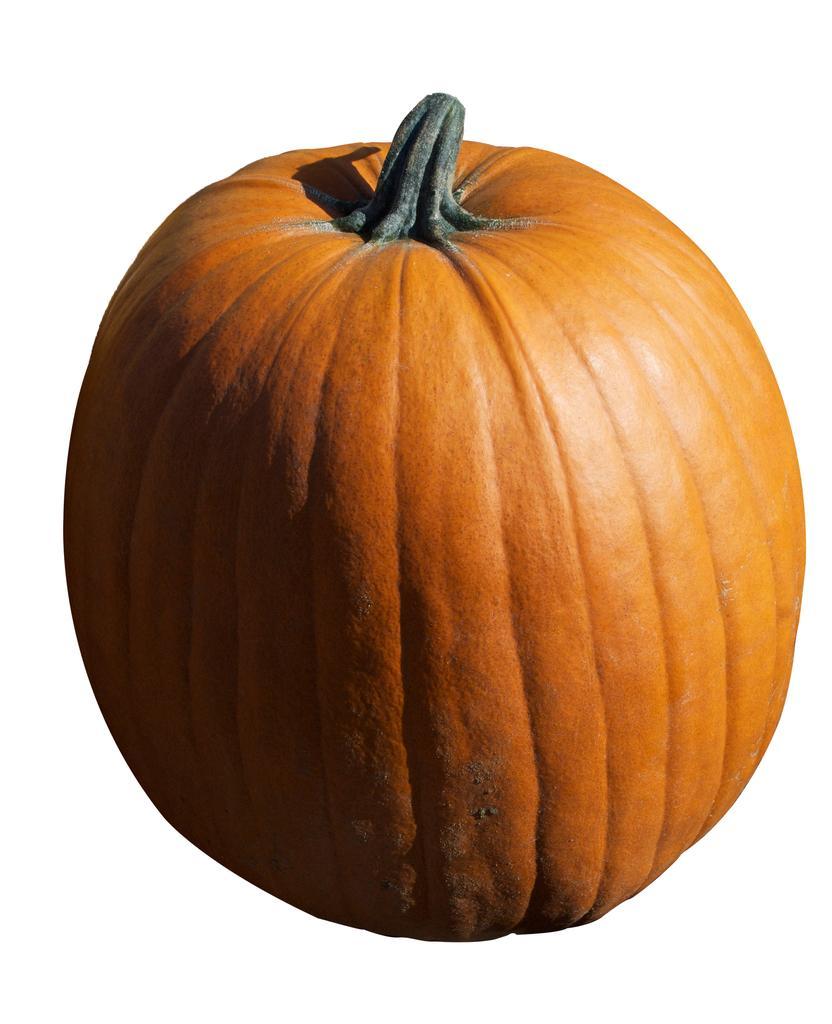Could you give a brief overview of what you see in this image? The picture consists of a pumpkin. The picture has white surface. 